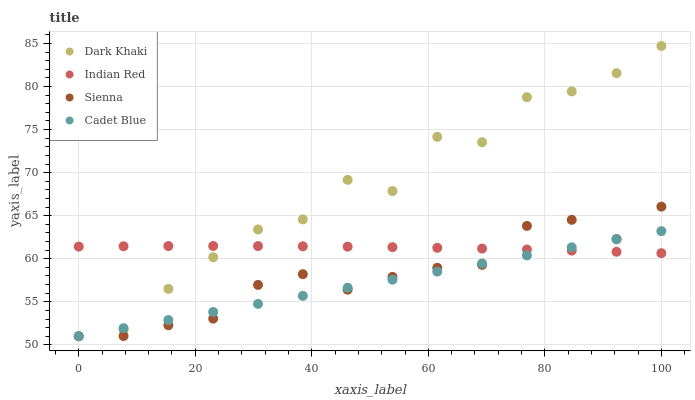Does Cadet Blue have the minimum area under the curve?
Answer yes or no. Yes. Does Dark Khaki have the maximum area under the curve?
Answer yes or no. Yes. Does Sienna have the minimum area under the curve?
Answer yes or no. No. Does Sienna have the maximum area under the curve?
Answer yes or no. No. Is Cadet Blue the smoothest?
Answer yes or no. Yes. Is Dark Khaki the roughest?
Answer yes or no. Yes. Is Sienna the smoothest?
Answer yes or no. No. Is Sienna the roughest?
Answer yes or no. No. Does Dark Khaki have the lowest value?
Answer yes or no. Yes. Does Indian Red have the lowest value?
Answer yes or no. No. Does Dark Khaki have the highest value?
Answer yes or no. Yes. Does Sienna have the highest value?
Answer yes or no. No. Does Sienna intersect Dark Khaki?
Answer yes or no. Yes. Is Sienna less than Dark Khaki?
Answer yes or no. No. Is Sienna greater than Dark Khaki?
Answer yes or no. No. 